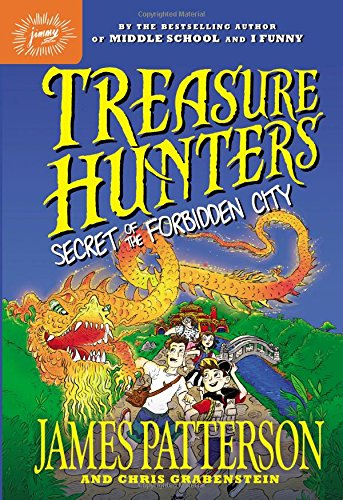Can you tell more about the plot of this book based on the cover? The cover of 'Treasure Hunters: Secret of the Forbidden City' depicts a dynamic scene with a mythical dragon and characters in action, suggesting an exciting adventure involving ancient legends and the quest for hidden treasures in exotic locations. 